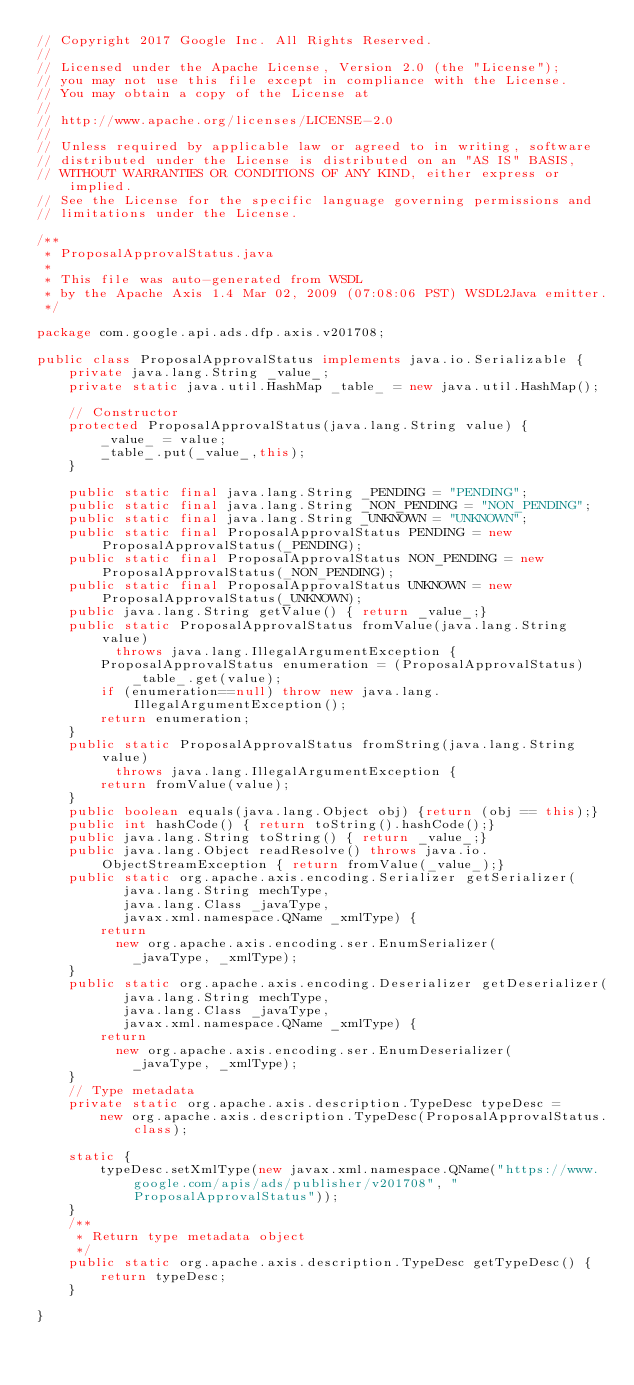<code> <loc_0><loc_0><loc_500><loc_500><_Java_>// Copyright 2017 Google Inc. All Rights Reserved.
//
// Licensed under the Apache License, Version 2.0 (the "License");
// you may not use this file except in compliance with the License.
// You may obtain a copy of the License at
//
// http://www.apache.org/licenses/LICENSE-2.0
//
// Unless required by applicable law or agreed to in writing, software
// distributed under the License is distributed on an "AS IS" BASIS,
// WITHOUT WARRANTIES OR CONDITIONS OF ANY KIND, either express or implied.
// See the License for the specific language governing permissions and
// limitations under the License.

/**
 * ProposalApprovalStatus.java
 *
 * This file was auto-generated from WSDL
 * by the Apache Axis 1.4 Mar 02, 2009 (07:08:06 PST) WSDL2Java emitter.
 */

package com.google.api.ads.dfp.axis.v201708;

public class ProposalApprovalStatus implements java.io.Serializable {
    private java.lang.String _value_;
    private static java.util.HashMap _table_ = new java.util.HashMap();

    // Constructor
    protected ProposalApprovalStatus(java.lang.String value) {
        _value_ = value;
        _table_.put(_value_,this);
    }

    public static final java.lang.String _PENDING = "PENDING";
    public static final java.lang.String _NON_PENDING = "NON_PENDING";
    public static final java.lang.String _UNKNOWN = "UNKNOWN";
    public static final ProposalApprovalStatus PENDING = new ProposalApprovalStatus(_PENDING);
    public static final ProposalApprovalStatus NON_PENDING = new ProposalApprovalStatus(_NON_PENDING);
    public static final ProposalApprovalStatus UNKNOWN = new ProposalApprovalStatus(_UNKNOWN);
    public java.lang.String getValue() { return _value_;}
    public static ProposalApprovalStatus fromValue(java.lang.String value)
          throws java.lang.IllegalArgumentException {
        ProposalApprovalStatus enumeration = (ProposalApprovalStatus)
            _table_.get(value);
        if (enumeration==null) throw new java.lang.IllegalArgumentException();
        return enumeration;
    }
    public static ProposalApprovalStatus fromString(java.lang.String value)
          throws java.lang.IllegalArgumentException {
        return fromValue(value);
    }
    public boolean equals(java.lang.Object obj) {return (obj == this);}
    public int hashCode() { return toString().hashCode();}
    public java.lang.String toString() { return _value_;}
    public java.lang.Object readResolve() throws java.io.ObjectStreamException { return fromValue(_value_);}
    public static org.apache.axis.encoding.Serializer getSerializer(
           java.lang.String mechType, 
           java.lang.Class _javaType,  
           javax.xml.namespace.QName _xmlType) {
        return 
          new org.apache.axis.encoding.ser.EnumSerializer(
            _javaType, _xmlType);
    }
    public static org.apache.axis.encoding.Deserializer getDeserializer(
           java.lang.String mechType, 
           java.lang.Class _javaType,  
           javax.xml.namespace.QName _xmlType) {
        return 
          new org.apache.axis.encoding.ser.EnumDeserializer(
            _javaType, _xmlType);
    }
    // Type metadata
    private static org.apache.axis.description.TypeDesc typeDesc =
        new org.apache.axis.description.TypeDesc(ProposalApprovalStatus.class);

    static {
        typeDesc.setXmlType(new javax.xml.namespace.QName("https://www.google.com/apis/ads/publisher/v201708", "ProposalApprovalStatus"));
    }
    /**
     * Return type metadata object
     */
    public static org.apache.axis.description.TypeDesc getTypeDesc() {
        return typeDesc;
    }

}
</code> 